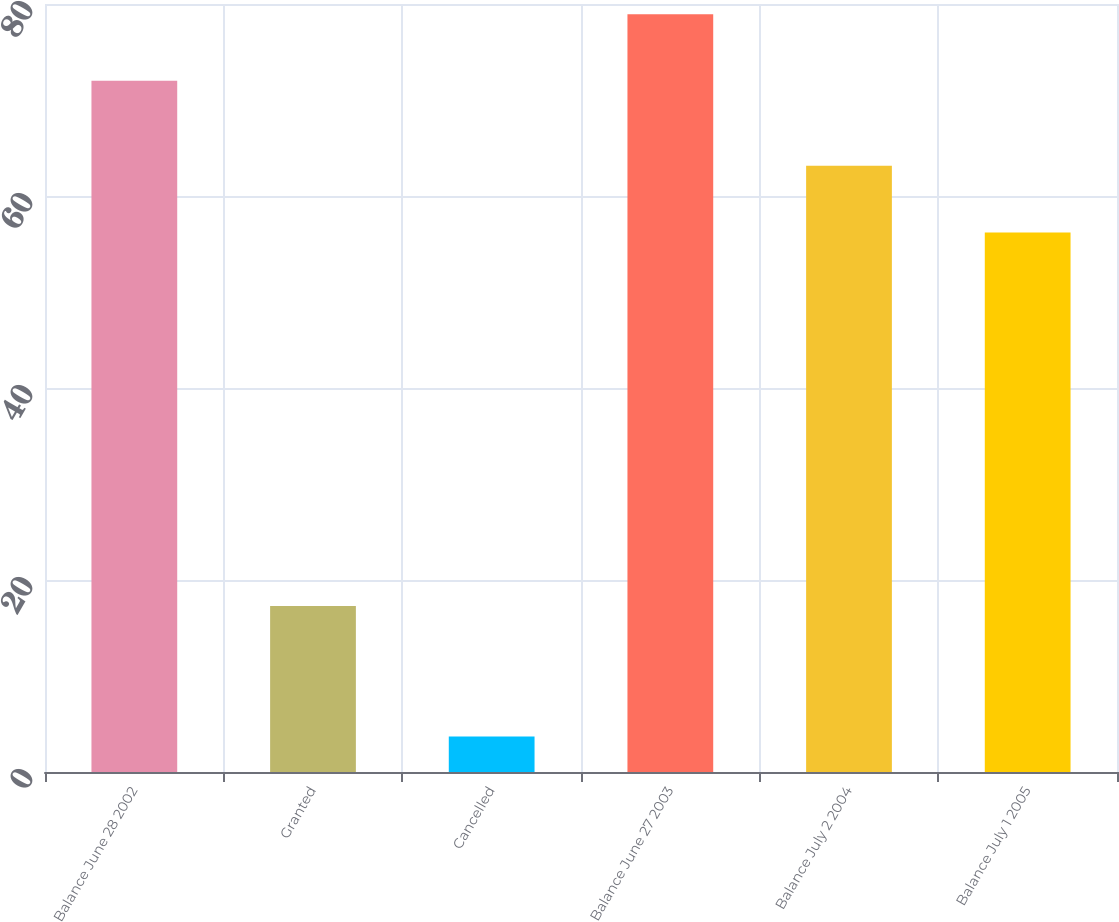Convert chart. <chart><loc_0><loc_0><loc_500><loc_500><bar_chart><fcel>Balance June 28 2002<fcel>Granted<fcel>Cancelled<fcel>Balance June 27 2003<fcel>Balance July 2 2004<fcel>Balance July 1 2005<nl><fcel>72<fcel>17.3<fcel>3.7<fcel>78.94<fcel>63.14<fcel>56.2<nl></chart> 